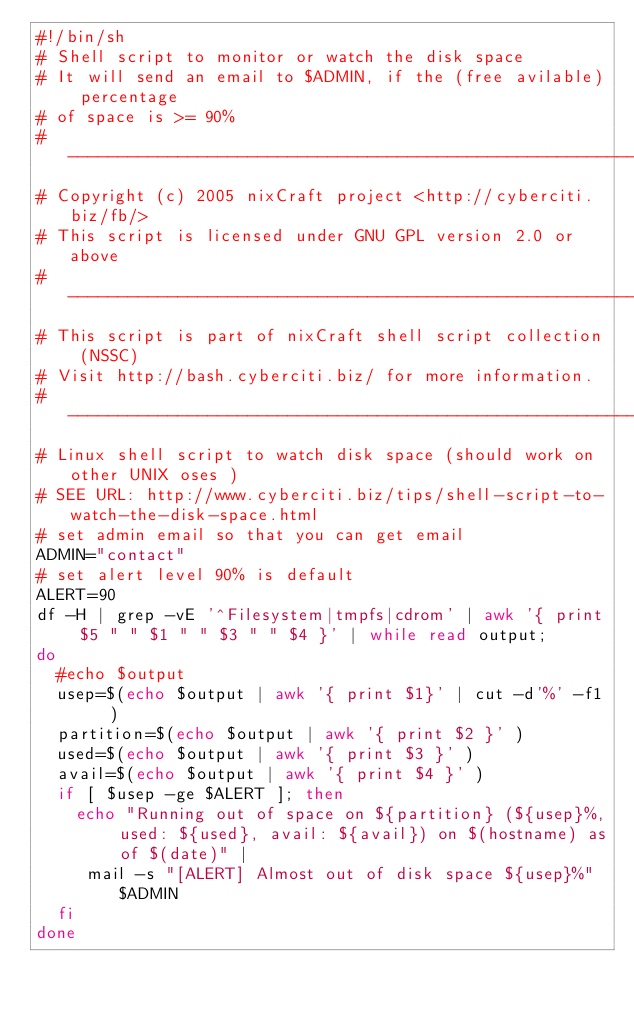Convert code to text. <code><loc_0><loc_0><loc_500><loc_500><_Bash_>#!/bin/sh
# Shell script to monitor or watch the disk space
# It will send an email to $ADMIN, if the (free avilable) percentage 
# of space is >= 90% 
# -------------------------------------------------------------------------
# Copyright (c) 2005 nixCraft project <http://cyberciti.biz/fb/>
# This script is licensed under GNU GPL version 2.0 or above
# -------------------------------------------------------------------------
# This script is part of nixCraft shell script collection (NSSC)
# Visit http://bash.cyberciti.biz/ for more information.
# ----------------------------------------------------------------------
# Linux shell script to watch disk space (should work on other UNIX oses )
# SEE URL: http://www.cyberciti.biz/tips/shell-script-to-watch-the-disk-space.html
# set admin email so that you can get email
ADMIN="contact"
# set alert level 90% is default
ALERT=90
df -H | grep -vE '^Filesystem|tmpfs|cdrom' | awk '{ print $5 " " $1 " " $3 " " $4 }' | while read output;
do
  #echo $output
  usep=$(echo $output | awk '{ print $1}' | cut -d'%' -f1  )
  partition=$(echo $output | awk '{ print $2 }' )
  used=$(echo $output | awk '{ print $3 }' )
  avail=$(echo $output | awk '{ print $4 }' )
  if [ $usep -ge $ALERT ]; then
    echo "Running out of space on ${partition} (${usep}%, used: ${used}, avail: ${avail}) on $(hostname) as of $(date)" | 
     mail -s "[ALERT] Almost out of disk space ${usep}%" $ADMIN
  fi
done
</code> 